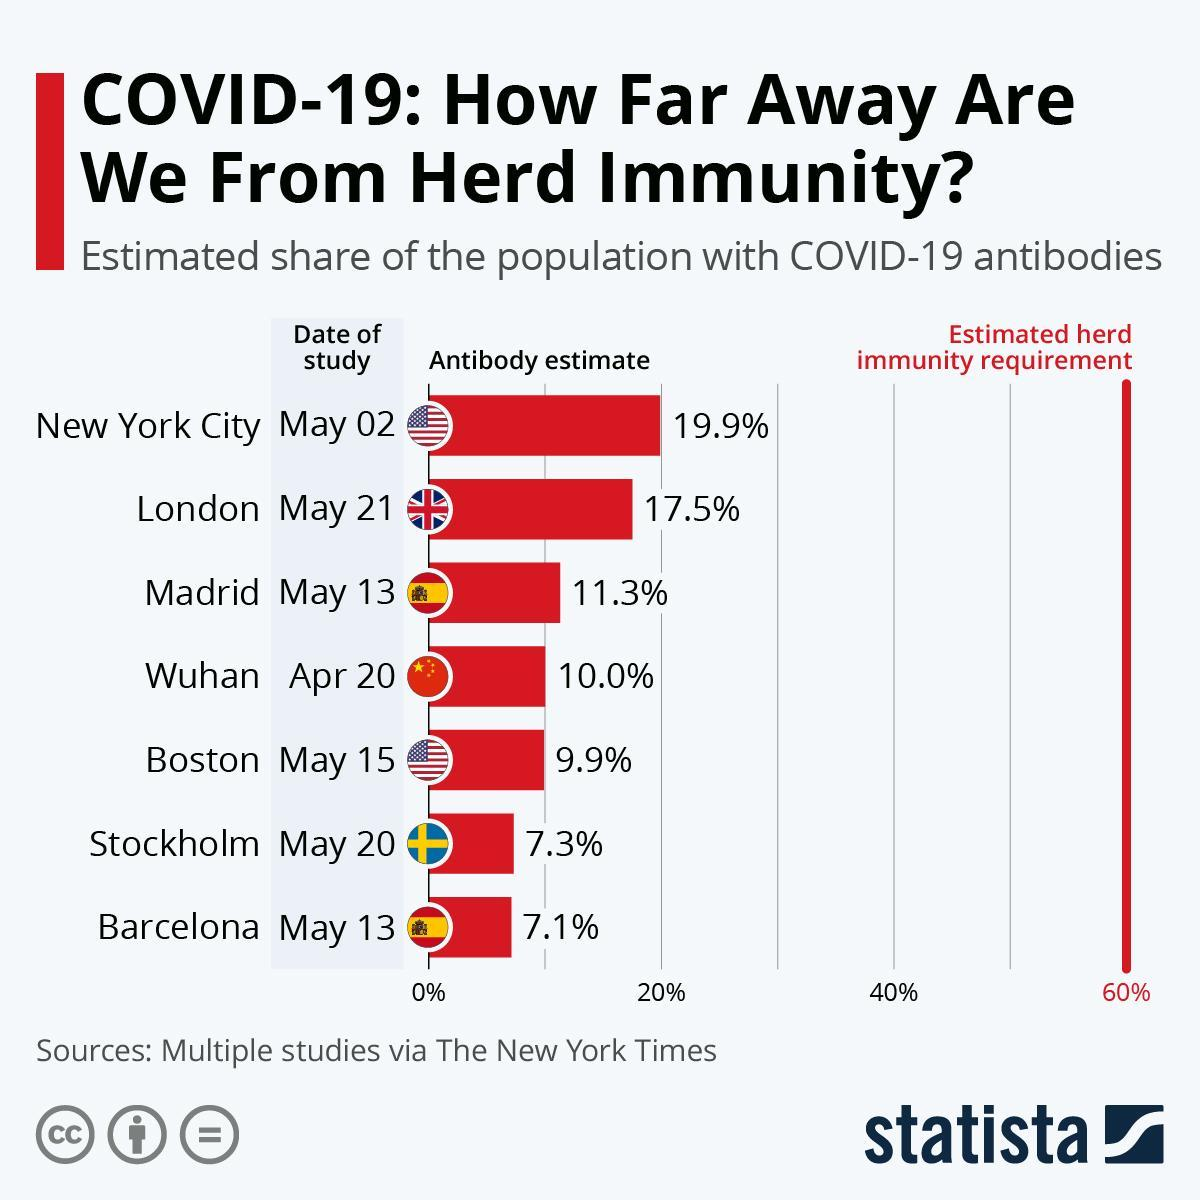Which cities have antibody estimate below 10%?
Answer the question with a short phrase. Boston, Stockholm, Barcelona Which city has second highest antibody estimate? London What is the estimated herd immunity requirement? 60% Which city is leading in antibody estimate percentage? New York City What percent more of antibody estimate should Wuhan reach to attain herd immunity requirement? 50% 